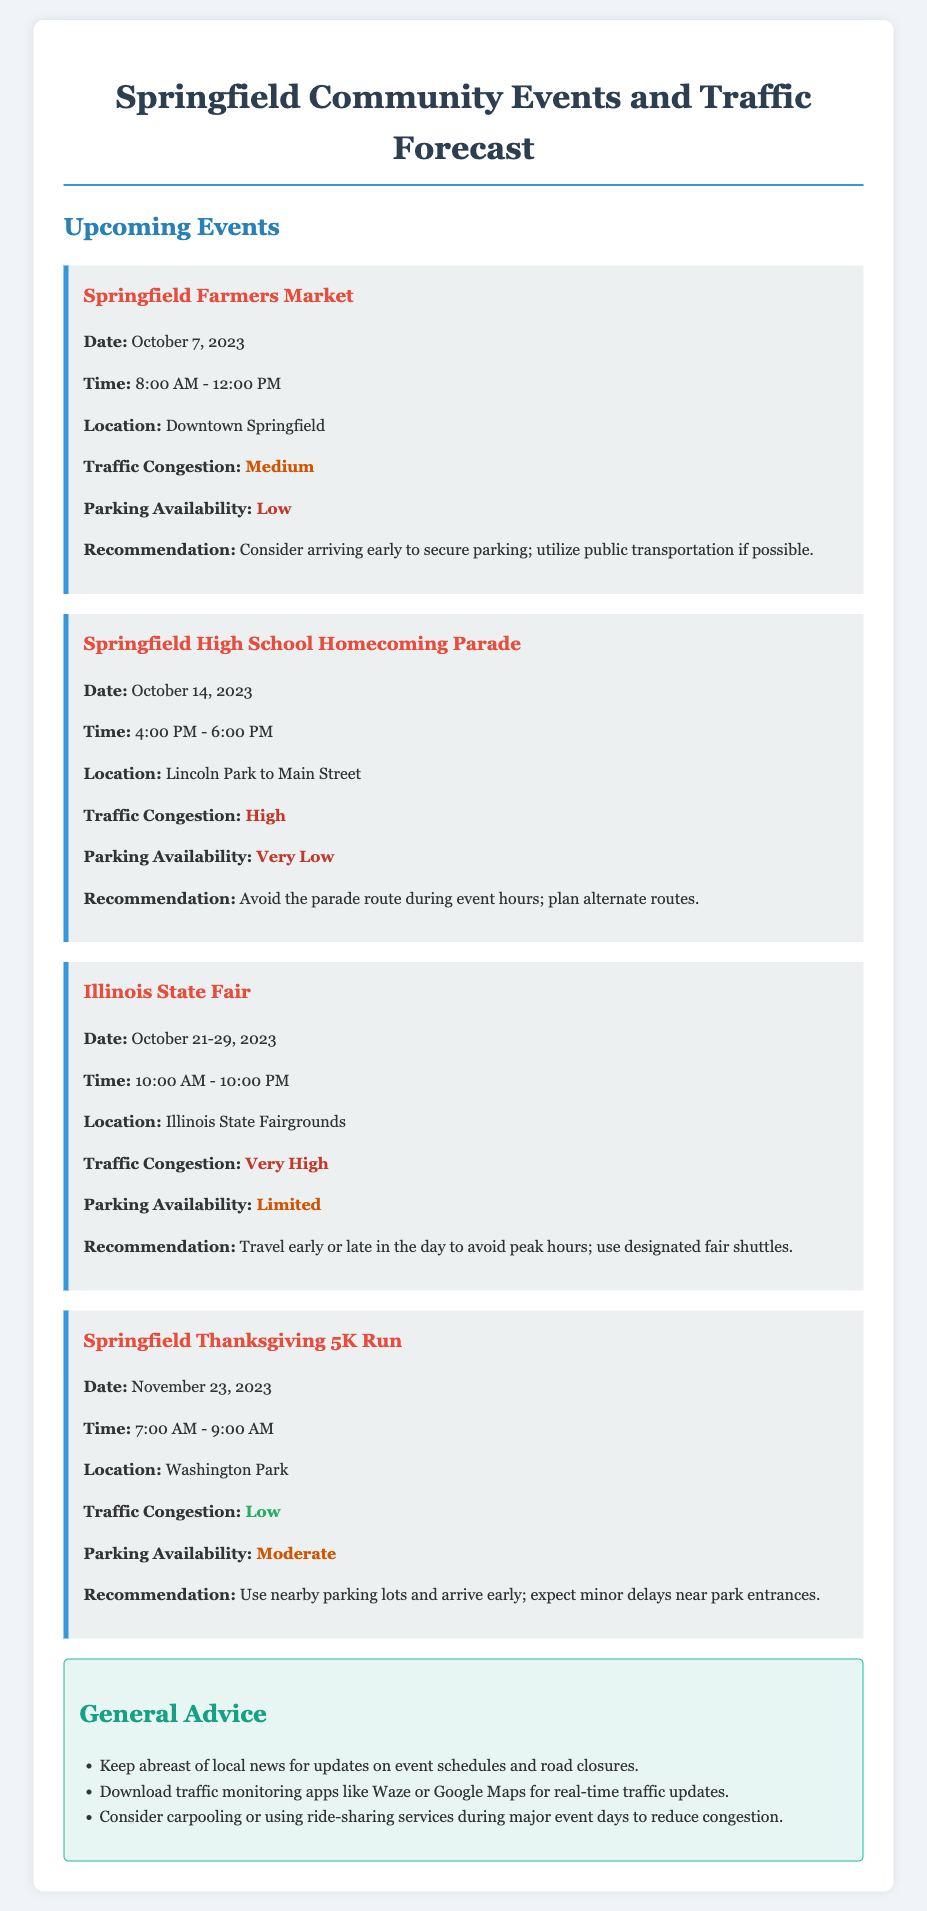What is the date of the Springfield Farmers Market? The date is explicitly stated in the document as October 7, 2023.
Answer: October 7, 2023 What is the time of the Illinois State Fair? The document specifies the time for the Illinois State Fair as 10:00 AM - 10:00 PM.
Answer: 10:00 AM - 10:00 PM What is the traffic congestion impact of the Homecoming Parade? The impact is categorized in the document as high.
Answer: High How long does the Illinois State Fair last? The duration is given as October 21-29, 2023, which indicates it lasts 9 days.
Answer: 9 days What type of advice is suggested for attending events? The document includes specific recommendations, such as downloading traffic monitoring apps.
Answer: Download traffic monitoring apps What is the parking availability at the Springfield Farmers Market? The document mentions that parking availability is low for this event.
Answer: Low What route should be avoided during the Homecoming Parade? The document recommends avoiding the parade route during event hours.
Answer: Parade route What is the traffic congestion expected for the Thanksgiving 5K Run? The document indicates that traffic congestion is low for this event.
Answer: Low 